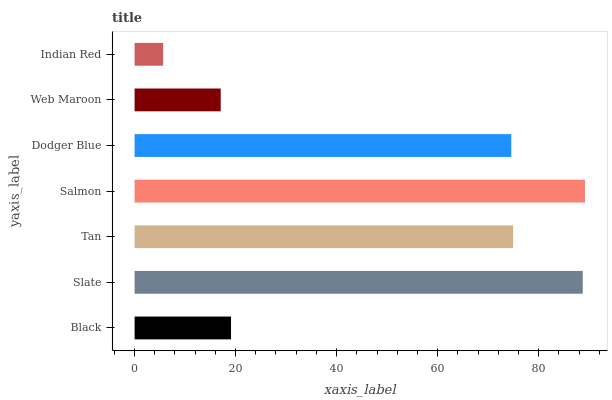Is Indian Red the minimum?
Answer yes or no. Yes. Is Salmon the maximum?
Answer yes or no. Yes. Is Slate the minimum?
Answer yes or no. No. Is Slate the maximum?
Answer yes or no. No. Is Slate greater than Black?
Answer yes or no. Yes. Is Black less than Slate?
Answer yes or no. Yes. Is Black greater than Slate?
Answer yes or no. No. Is Slate less than Black?
Answer yes or no. No. Is Dodger Blue the high median?
Answer yes or no. Yes. Is Dodger Blue the low median?
Answer yes or no. Yes. Is Slate the high median?
Answer yes or no. No. Is Web Maroon the low median?
Answer yes or no. No. 